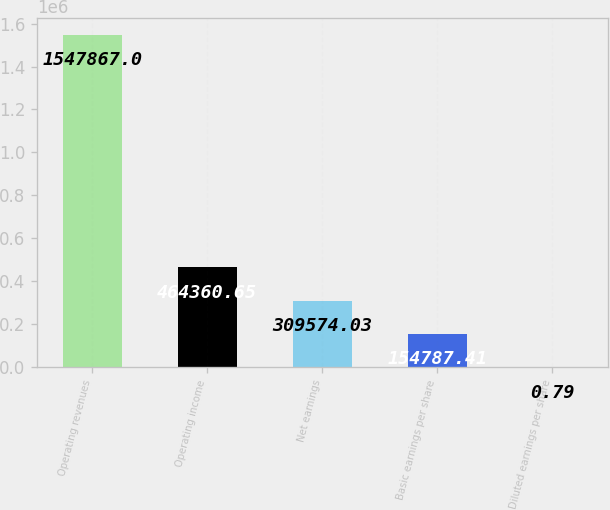Convert chart to OTSL. <chart><loc_0><loc_0><loc_500><loc_500><bar_chart><fcel>Operating revenues<fcel>Operating income<fcel>Net earnings<fcel>Basic earnings per share<fcel>Diluted earnings per share<nl><fcel>1.54787e+06<fcel>464361<fcel>309574<fcel>154787<fcel>0.79<nl></chart> 